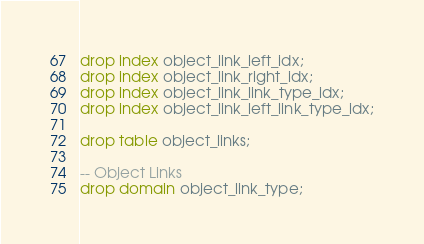<code> <loc_0><loc_0><loc_500><loc_500><_SQL_>drop index object_link_left_idx;
drop index object_link_right_idx;
drop index object_link_link_type_idx;
drop index object_link_left_link_type_idx;

drop table object_links;

-- Object Links
drop domain object_link_type;
</code> 